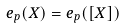<formula> <loc_0><loc_0><loc_500><loc_500>e _ { p } ( X ) = e _ { p } ( [ X ] )</formula> 